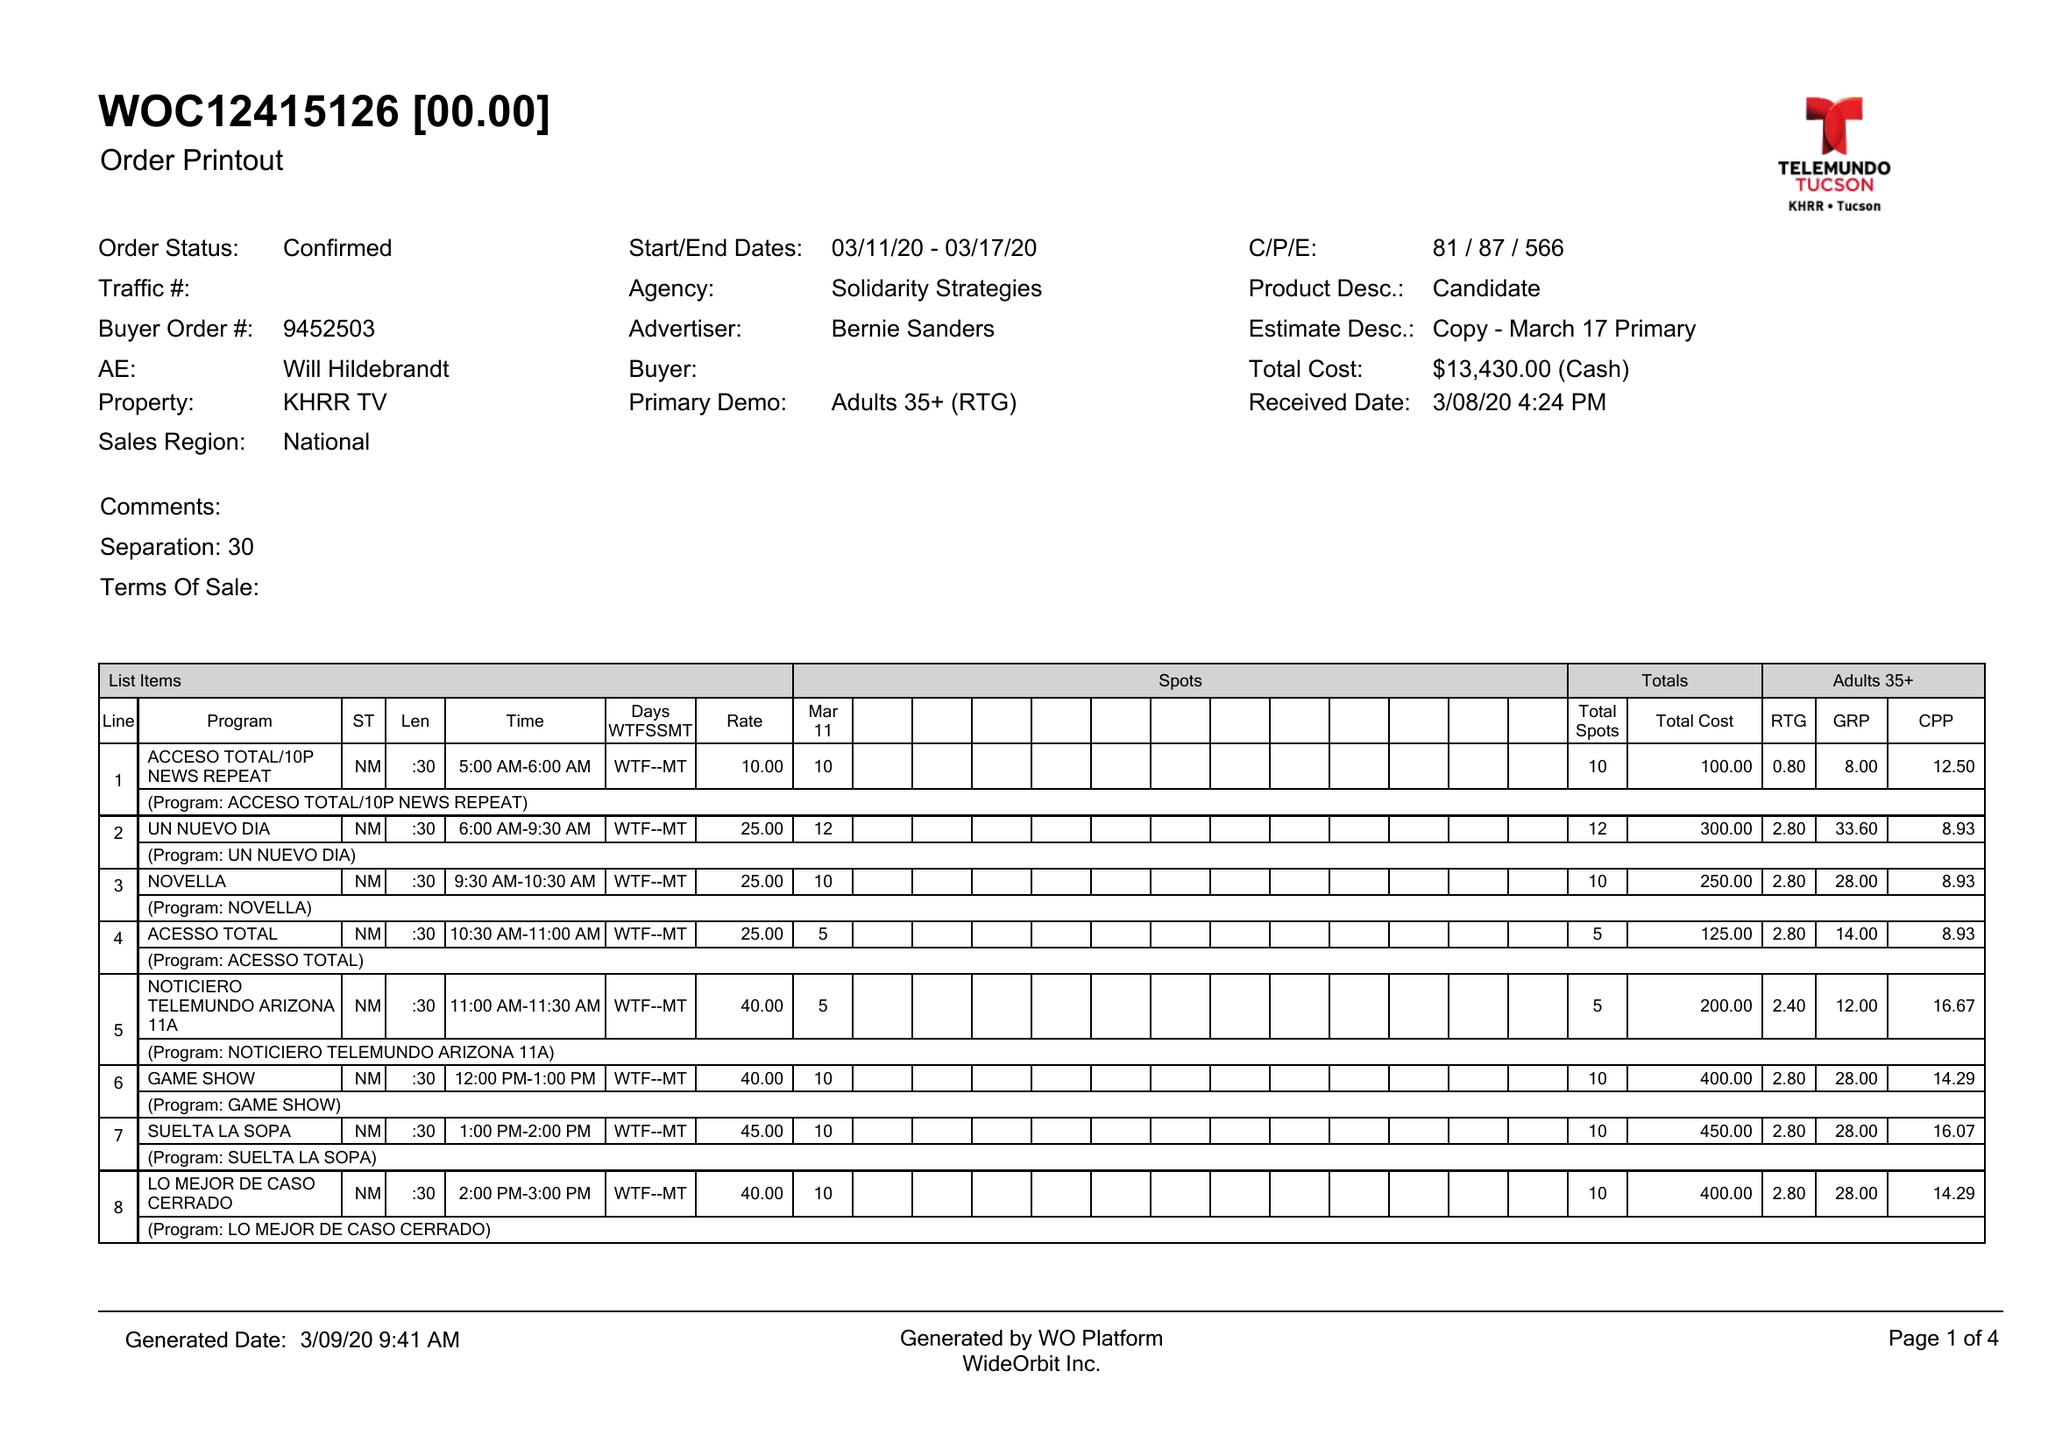What is the value for the flight_to?
Answer the question using a single word or phrase. 03/17/20 